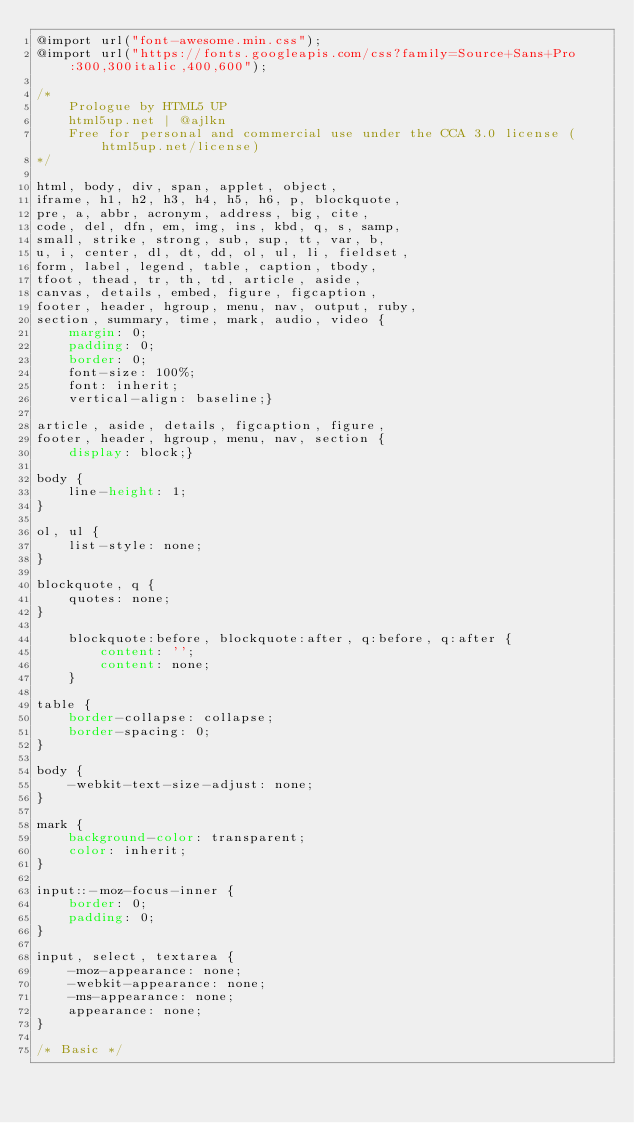<code> <loc_0><loc_0><loc_500><loc_500><_CSS_>@import url("font-awesome.min.css");
@import url("https://fonts.googleapis.com/css?family=Source+Sans+Pro:300,300italic,400,600");

/*
	Prologue by HTML5 UP
	html5up.net | @ajlkn
	Free for personal and commercial use under the CCA 3.0 license (html5up.net/license)
*/

html, body, div, span, applet, object,
iframe, h1, h2, h3, h4, h5, h6, p, blockquote,
pre, a, abbr, acronym, address, big, cite,
code, del, dfn, em, img, ins, kbd, q, s, samp,
small, strike, strong, sub, sup, tt, var, b,
u, i, center, dl, dt, dd, ol, ul, li, fieldset,
form, label, legend, table, caption, tbody,
tfoot, thead, tr, th, td, article, aside,
canvas, details, embed, figure, figcaption,
footer, header, hgroup, menu, nav, output, ruby,
section, summary, time, mark, audio, video {
	margin: 0;
	padding: 0;
	border: 0;
	font-size: 100%;
	font: inherit;
	vertical-align: baseline;}

article, aside, details, figcaption, figure,
footer, header, hgroup, menu, nav, section {
	display: block;}

body {
	line-height: 1;
}

ol, ul {
	list-style: none;
}

blockquote, q {
	quotes: none;
}

	blockquote:before, blockquote:after, q:before, q:after {
		content: '';
		content: none;
	}

table {
	border-collapse: collapse;
	border-spacing: 0;
}

body {
	-webkit-text-size-adjust: none;
}

mark {
	background-color: transparent;
	color: inherit;
}

input::-moz-focus-inner {
	border: 0;
	padding: 0;
}

input, select, textarea {
	-moz-appearance: none;
	-webkit-appearance: none;
	-ms-appearance: none;
	appearance: none;
}

/* Basic */
</code> 